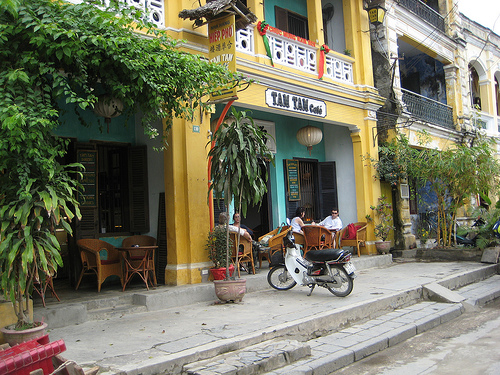<image>
Can you confirm if the bike is on the stair? No. The bike is not positioned on the stair. They may be near each other, but the bike is not supported by or resting on top of the stair. 